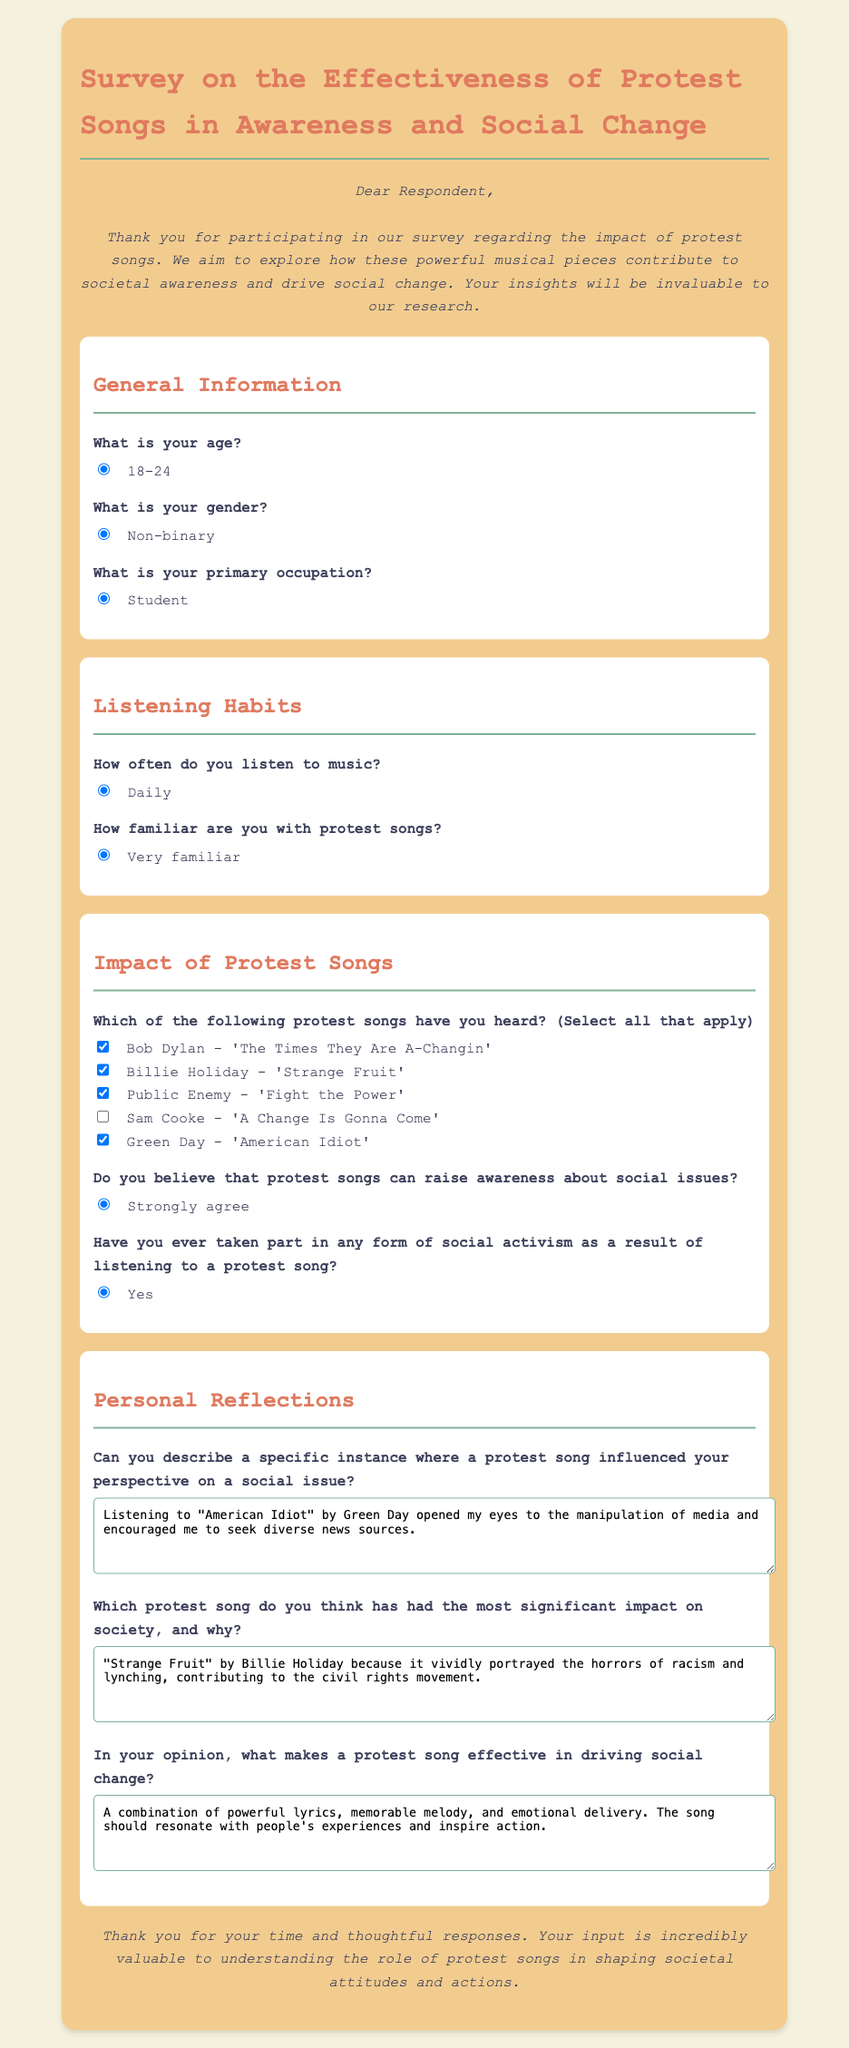What is the title of the survey? The title of the survey is explicitly stated in the document.
Answer: Survey on the Effectiveness of Protest Songs in Awareness and Social Change How many age options are provided in the survey? The specific section lists the available age options in the survey.
Answer: 1 Who is the artist of the song "Strange Fruit"? The survey mentions this song along with its artist directly.
Answer: Billie Holiday What is the occupation of the survey respondent? The document explicitly mentions the occupation of the included respondent.
Answer: Student Which protest song is mentioned as influencing perspectives on social issues? According to the personal reflections section, a specific song is described by the respondent.
Answer: American Idiot What was the response about the impact of protest songs on awareness? The document records the respondent's beliefs about the role of protest songs.
Answer: Strongly agree What specific social issue is highlighted by the song "Strange Fruit"? The survey describes the significance of this song in addressing specific societal issues.
Answer: Racism Which protest song is noted for its contribution to the civil rights movement? This detail is provided in the respondent's answer regarding impactful songs.
Answer: Strange Fruit What key element makes a protest song effective in driving social change? The respondent's opinion on effectiveness in driving social change is included in the personal reflections.
Answer: Powerful lyrics 